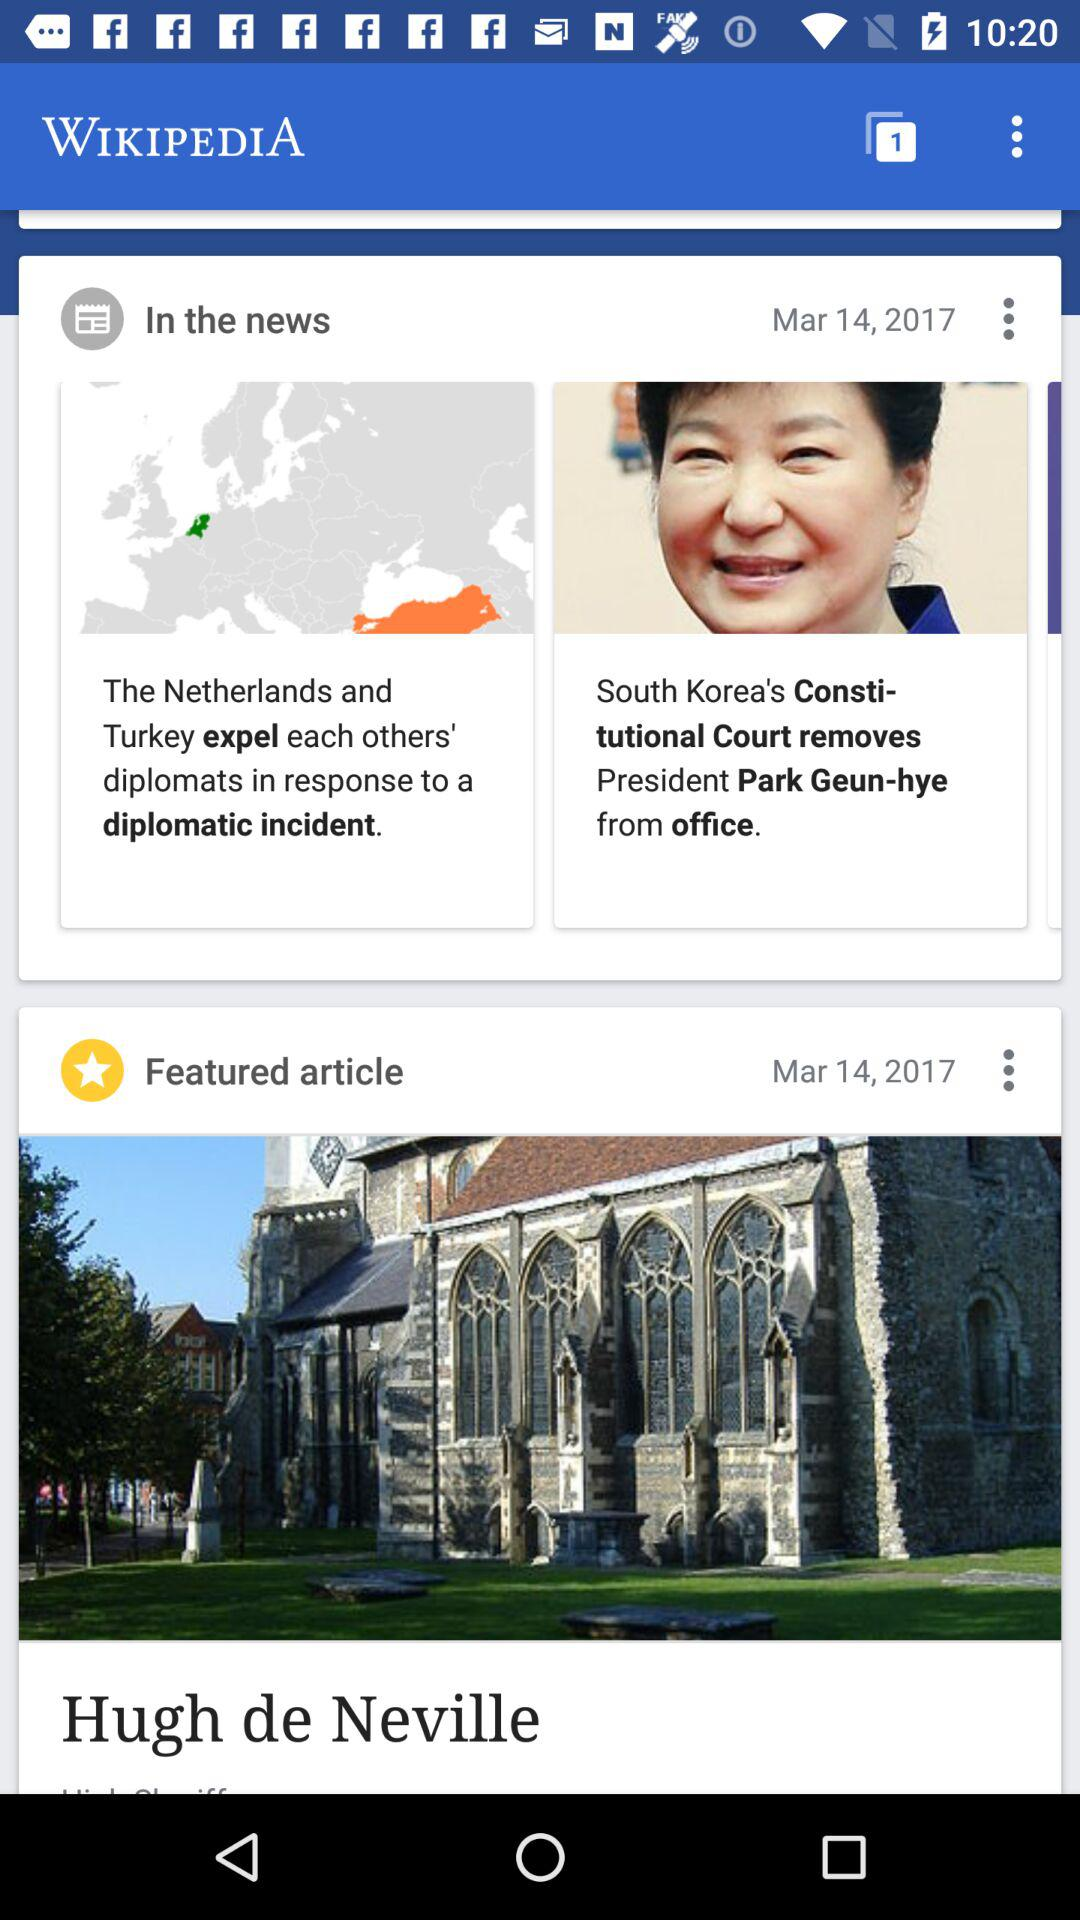What is the application name? The application name is "WIKIPEDIA". 